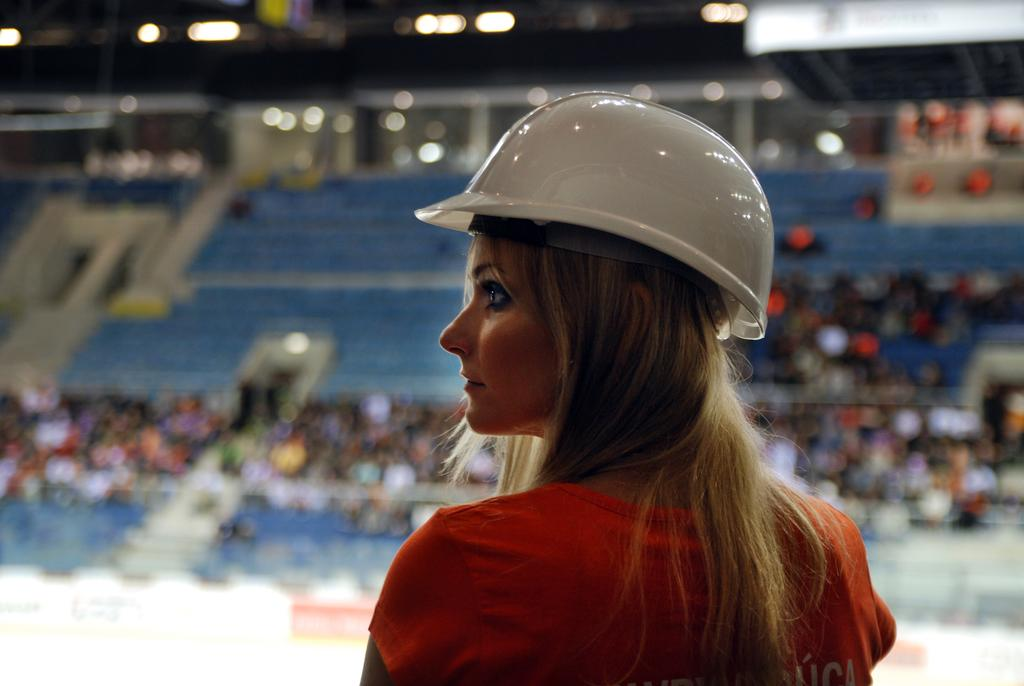Who is present in the image? There is a lady in the image. What is the lady wearing on her head? The lady is wearing a helmet. Can you describe the background of the image? The background is blurred, and it appears to be a stadium. What can be seen in the image besides the lady? There are lights in the image. What type of plants can be seen growing in the snow in the image? There is no snow or plants present in the image. 